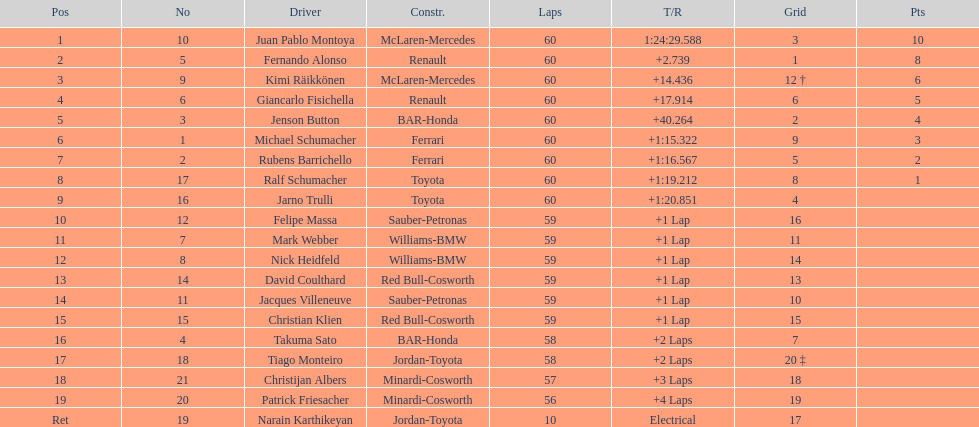Which driver has his grid at 2? Jenson Button. 